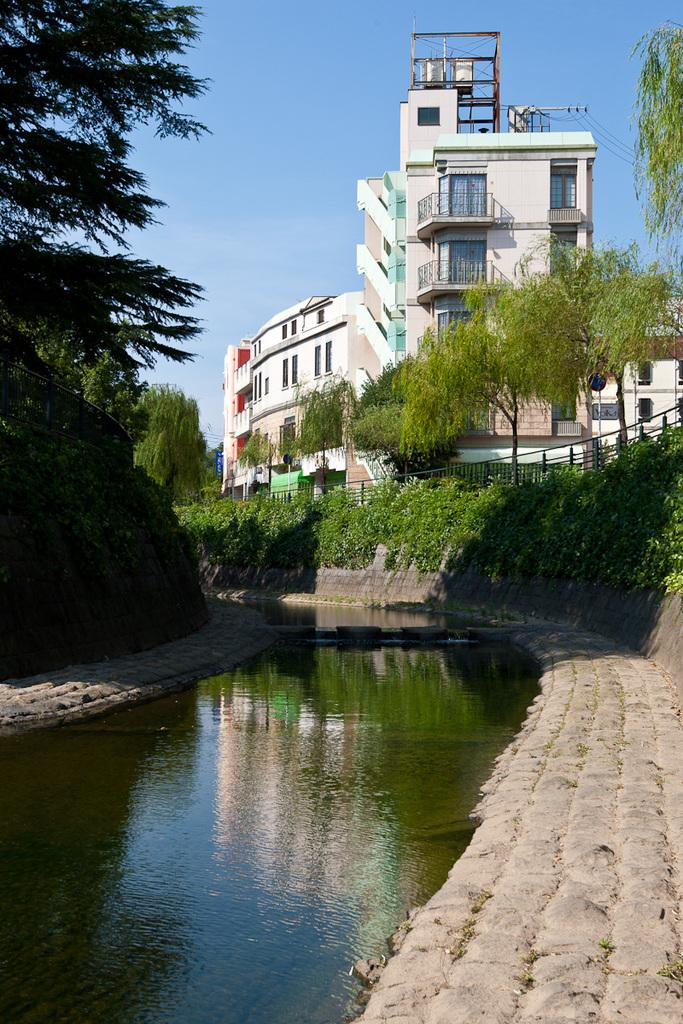What type of natural feature is present in the image? There is a lake in the image. Where are the trees located in the image? There are trees on both the left and right sides of the image. What structure can be seen at the top of the image? There is a building at the top of the image. What type of slope can be seen in the image? There is no slope present in the image. Can you see a car driving near the lake in the image? There is no car visible in the image. 